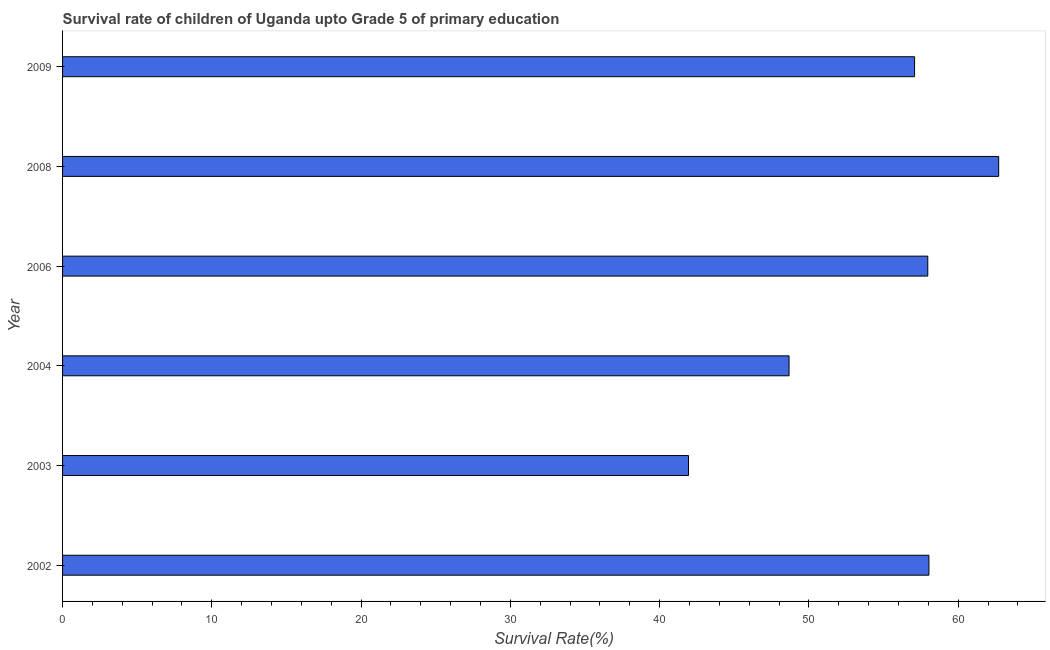What is the title of the graph?
Your answer should be very brief. Survival rate of children of Uganda upto Grade 5 of primary education. What is the label or title of the X-axis?
Provide a succinct answer. Survival Rate(%). What is the survival rate in 2002?
Ensure brevity in your answer.  58.04. Across all years, what is the maximum survival rate?
Give a very brief answer. 62.71. Across all years, what is the minimum survival rate?
Give a very brief answer. 41.93. In which year was the survival rate maximum?
Your answer should be compact. 2008. In which year was the survival rate minimum?
Offer a very short reply. 2003. What is the sum of the survival rate?
Give a very brief answer. 326.39. What is the difference between the survival rate in 2004 and 2009?
Make the answer very short. -8.41. What is the average survival rate per year?
Keep it short and to the point. 54.4. What is the median survival rate?
Ensure brevity in your answer.  57.52. Do a majority of the years between 2003 and 2008 (inclusive) have survival rate greater than 48 %?
Keep it short and to the point. Yes. What is the ratio of the survival rate in 2004 to that in 2008?
Ensure brevity in your answer.  0.78. Is the difference between the survival rate in 2002 and 2009 greater than the difference between any two years?
Give a very brief answer. No. What is the difference between the highest and the second highest survival rate?
Offer a terse response. 4.67. Is the sum of the survival rate in 2006 and 2008 greater than the maximum survival rate across all years?
Offer a very short reply. Yes. What is the difference between the highest and the lowest survival rate?
Provide a succinct answer. 20.78. How many years are there in the graph?
Offer a terse response. 6. What is the difference between two consecutive major ticks on the X-axis?
Provide a succinct answer. 10. What is the Survival Rate(%) in 2002?
Offer a terse response. 58.04. What is the Survival Rate(%) of 2003?
Provide a short and direct response. 41.93. What is the Survival Rate(%) of 2004?
Your answer should be compact. 48.67. What is the Survival Rate(%) in 2006?
Ensure brevity in your answer.  57.96. What is the Survival Rate(%) of 2008?
Offer a very short reply. 62.71. What is the Survival Rate(%) in 2009?
Your answer should be very brief. 57.08. What is the difference between the Survival Rate(%) in 2002 and 2003?
Your answer should be very brief. 16.1. What is the difference between the Survival Rate(%) in 2002 and 2004?
Your response must be concise. 9.37. What is the difference between the Survival Rate(%) in 2002 and 2006?
Provide a succinct answer. 0.08. What is the difference between the Survival Rate(%) in 2002 and 2008?
Ensure brevity in your answer.  -4.67. What is the difference between the Survival Rate(%) in 2002 and 2009?
Your answer should be compact. 0.96. What is the difference between the Survival Rate(%) in 2003 and 2004?
Make the answer very short. -6.73. What is the difference between the Survival Rate(%) in 2003 and 2006?
Your answer should be compact. -16.03. What is the difference between the Survival Rate(%) in 2003 and 2008?
Offer a very short reply. -20.78. What is the difference between the Survival Rate(%) in 2003 and 2009?
Make the answer very short. -15.14. What is the difference between the Survival Rate(%) in 2004 and 2006?
Keep it short and to the point. -9.29. What is the difference between the Survival Rate(%) in 2004 and 2008?
Give a very brief answer. -14.04. What is the difference between the Survival Rate(%) in 2004 and 2009?
Give a very brief answer. -8.41. What is the difference between the Survival Rate(%) in 2006 and 2008?
Make the answer very short. -4.75. What is the difference between the Survival Rate(%) in 2006 and 2009?
Keep it short and to the point. 0.88. What is the difference between the Survival Rate(%) in 2008 and 2009?
Make the answer very short. 5.63. What is the ratio of the Survival Rate(%) in 2002 to that in 2003?
Provide a short and direct response. 1.38. What is the ratio of the Survival Rate(%) in 2002 to that in 2004?
Keep it short and to the point. 1.19. What is the ratio of the Survival Rate(%) in 2002 to that in 2008?
Your answer should be compact. 0.93. What is the ratio of the Survival Rate(%) in 2002 to that in 2009?
Provide a succinct answer. 1.02. What is the ratio of the Survival Rate(%) in 2003 to that in 2004?
Your response must be concise. 0.86. What is the ratio of the Survival Rate(%) in 2003 to that in 2006?
Offer a very short reply. 0.72. What is the ratio of the Survival Rate(%) in 2003 to that in 2008?
Ensure brevity in your answer.  0.67. What is the ratio of the Survival Rate(%) in 2003 to that in 2009?
Your answer should be very brief. 0.73. What is the ratio of the Survival Rate(%) in 2004 to that in 2006?
Your answer should be very brief. 0.84. What is the ratio of the Survival Rate(%) in 2004 to that in 2008?
Your answer should be very brief. 0.78. What is the ratio of the Survival Rate(%) in 2004 to that in 2009?
Keep it short and to the point. 0.85. What is the ratio of the Survival Rate(%) in 2006 to that in 2008?
Offer a terse response. 0.92. What is the ratio of the Survival Rate(%) in 2006 to that in 2009?
Give a very brief answer. 1.02. What is the ratio of the Survival Rate(%) in 2008 to that in 2009?
Give a very brief answer. 1.1. 